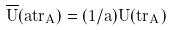Convert formula to latex. <formula><loc_0><loc_0><loc_500><loc_500>\overline { U } ( a \vec { t } { r } _ { A } ) = ( 1 / a ) U ( \vec { t } { r } _ { A } )</formula> 